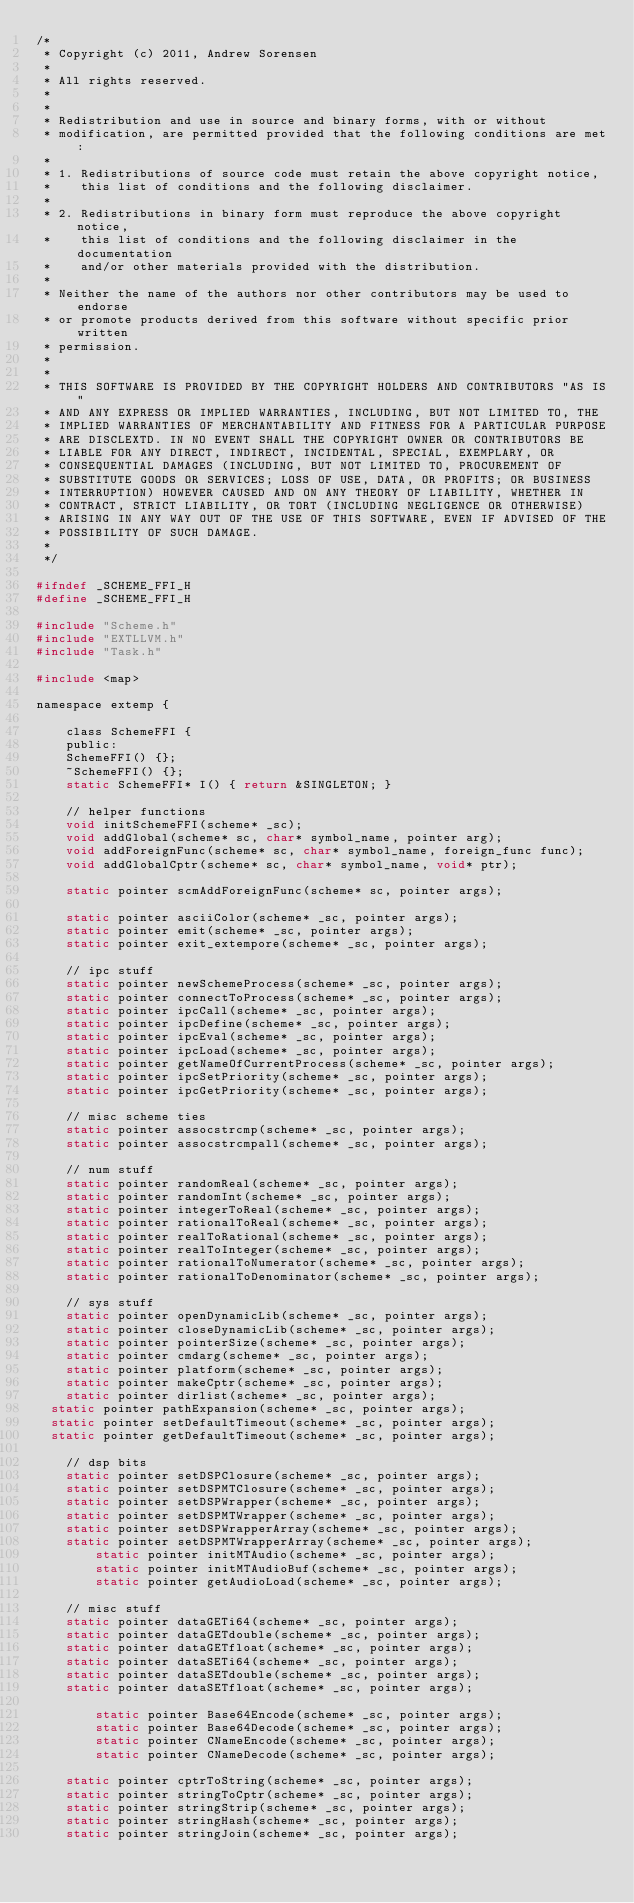<code> <loc_0><loc_0><loc_500><loc_500><_C_>/*
 * Copyright (c) 2011, Andrew Sorensen
 *
 * All rights reserved.
 *
 *
 * Redistribution and use in source and binary forms, with or without 
 * modification, are permitted provided that the following conditions are met:
 *
 * 1. Redistributions of source code must retain the above copyright notice, 
 *    this list of conditions and the following disclaimer.
 *
 * 2. Redistributions in binary form must reproduce the above copyright notice,
 *    this list of conditions and the following disclaimer in the documentation 
 *    and/or other materials provided with the distribution.
 *
 * Neither the name of the authors nor other contributors may be used to endorse
 * or promote products derived from this software without specific prior written 
 * permission.
 *
 *
 * THIS SOFTWARE IS PROVIDED BY THE COPYRIGHT HOLDERS AND CONTRIBUTORS "AS IS" 
 * AND ANY EXPRESS OR IMPLIED WARRANTIES, INCLUDING, BUT NOT LIMITED TO, THE 
 * IMPLIED WARRANTIES OF MERCHANTABILITY AND FITNESS FOR A PARTICULAR PURPOSE 
 * ARE DISCLEXTD. IN NO EVENT SHALL THE COPYRIGHT OWNER OR CONTRIBUTORS BE 
 * LIABLE FOR ANY DIRECT, INDIRECT, INCIDENTAL, SPECIAL, EXEMPLARY, OR 
 * CONSEQUENTIAL DAMAGES (INCLUDING, BUT NOT LIMITED TO, PROCUREMENT OF 
 * SUBSTITUTE GOODS OR SERVICES; LOSS OF USE, DATA, OR PROFITS; OR BUSINESS 
 * INTERRUPTION) HOWEVER CAUSED AND ON ANY THEORY OF LIABILITY, WHETHER IN 
 * CONTRACT, STRICT LIABILITY, OR TORT (INCLUDING NEGLIGENCE OR OTHERWISE) 
 * ARISING IN ANY WAY OUT OF THE USE OF THIS SOFTWARE, EVEN IF ADVISED OF THE 
 * POSSIBILITY OF SUCH DAMAGE.
 *
 */

#ifndef _SCHEME_FFI_H
#define _SCHEME_FFI_H

#include "Scheme.h"
#include "EXTLLVM.h"
#include "Task.h"

#include <map>

namespace extemp {

    class SchemeFFI {
    public:
	SchemeFFI() {};
	~SchemeFFI() {};
	static SchemeFFI* I() { return &SINGLETON; }
		
	// helper functions
	void initSchemeFFI(scheme* _sc);		
	void addGlobal(scheme* sc, char* symbol_name, pointer arg);
	void addForeignFunc(scheme* sc, char* symbol_name, foreign_func func);
	void addGlobalCptr(scheme* sc, char* symbol_name, void* ptr);		

	static pointer scmAddForeignFunc(scheme* sc, pointer args);
		
	static pointer asciiColor(scheme* _sc, pointer args);
	static pointer emit(scheme* _sc, pointer args);
	static pointer exit_extempore(scheme* _sc, pointer args);

	// ipc stuff
	static pointer newSchemeProcess(scheme* _sc, pointer args);
	static pointer connectToProcess(scheme* _sc, pointer args);
	static pointer ipcCall(scheme* _sc, pointer args);
	static pointer ipcDefine(scheme* _sc, pointer args);
	static pointer ipcEval(scheme* _sc, pointer args);
	static pointer ipcLoad(scheme* _sc, pointer args);
	static pointer getNameOfCurrentProcess(scheme* _sc, pointer args);
	static pointer ipcSetPriority(scheme* _sc, pointer args);
	static pointer ipcGetPriority(scheme* _sc, pointer args);

	// misc scheme ties 
	static pointer assocstrcmp(scheme* _sc, pointer args);
	static pointer assocstrcmpall(scheme* _sc, pointer args);

	// num stuff
	static pointer randomReal(scheme* _sc, pointer args);
	static pointer randomInt(scheme* _sc, pointer args);
	static pointer integerToReal(scheme* _sc, pointer args);
	static pointer rationalToReal(scheme* _sc, pointer args);
	static pointer realToRational(scheme* _sc, pointer args);
	static pointer realToInteger(scheme* _sc, pointer args);
	static pointer rationalToNumerator(scheme* _sc, pointer args);
	static pointer rationalToDenominator(scheme* _sc, pointer args);
		
	// sys stuff
	static pointer openDynamicLib(scheme* _sc, pointer args);
	static pointer closeDynamicLib(scheme* _sc, pointer args);		
	static pointer pointerSize(scheme* _sc, pointer args);
	static pointer cmdarg(scheme* _sc, pointer args);
	static pointer platform(scheme* _sc, pointer args);
	static pointer makeCptr(scheme* _sc, pointer args);
	static pointer dirlist(scheme* _sc, pointer args);
  static pointer pathExpansion(scheme* _sc, pointer args);
  static pointer setDefaultTimeout(scheme* _sc, pointer args);
  static pointer getDefaultTimeout(scheme* _sc, pointer args); 
  
	// dsp bits
	static pointer setDSPClosure(scheme* _sc, pointer args);
	static pointer setDSPMTClosure(scheme* _sc, pointer args);
	static pointer setDSPWrapper(scheme* _sc, pointer args);
	static pointer setDSPMTWrapper(scheme* _sc, pointer args);
	static pointer setDSPWrapperArray(scheme* _sc, pointer args);
	static pointer setDSPMTWrapperArray(scheme* _sc, pointer args);
        static pointer initMTAudio(scheme* _sc, pointer args);
        static pointer initMTAudioBuf(scheme* _sc, pointer args);
        static pointer getAudioLoad(scheme* _sc, pointer args);
		
	// misc stuff
	static pointer dataGETi64(scheme* _sc, pointer args);
	static pointer dataGETdouble(scheme* _sc, pointer args);	
	static pointer dataGETfloat(scheme* _sc, pointer args);	
	static pointer dataSETi64(scheme* _sc, pointer args);
	static pointer dataSETdouble(scheme* _sc, pointer args);
	static pointer dataSETfloat(scheme* _sc, pointer args);

        static pointer Base64Encode(scheme* _sc, pointer args);
        static pointer Base64Decode(scheme* _sc, pointer args);
        static pointer CNameEncode(scheme* _sc, pointer args);
        static pointer CNameDecode(scheme* _sc, pointer args);

	static pointer cptrToString(scheme* _sc, pointer args);
	static pointer stringToCptr(scheme* _sc, pointer args);
	static pointer stringStrip(scheme* _sc, pointer args);
	static pointer stringHash(scheme* _sc, pointer args);
	static pointer stringJoin(scheme* _sc, pointer args);</code> 